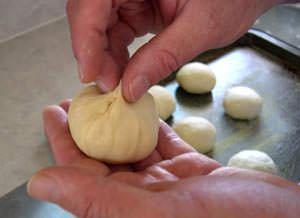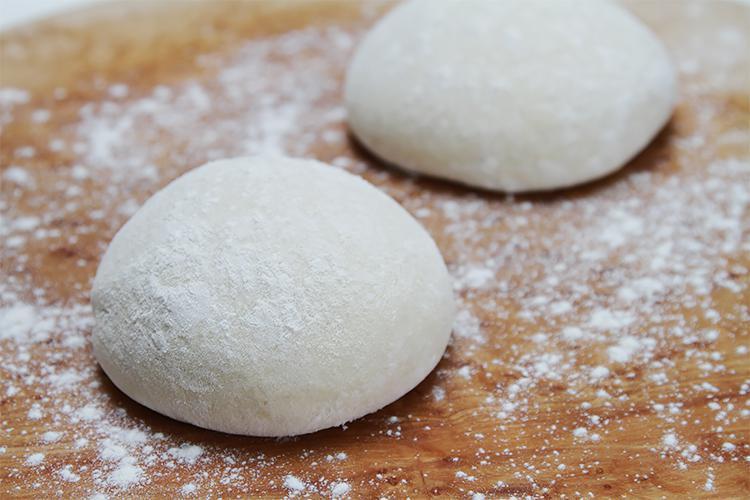The first image is the image on the left, the second image is the image on the right. For the images shown, is this caption "A wooden rolling pin is seen in the image on the left." true? Answer yes or no. No. The first image is the image on the left, the second image is the image on the right. Given the left and right images, does the statement "In one of the images there is a rolling pin." hold true? Answer yes or no. No. 